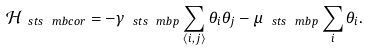Convert formula to latex. <formula><loc_0><loc_0><loc_500><loc_500>\mathcal { H } _ { \ s t s \ m b { c o r } } = - \gamma _ { \ s t s \ m b { p } } \sum _ { \left < i , j \right > } \theta _ { i } \theta _ { j } - \mu _ { \ s t s \ m b { p } } \sum _ { i } \theta _ { i } .</formula> 